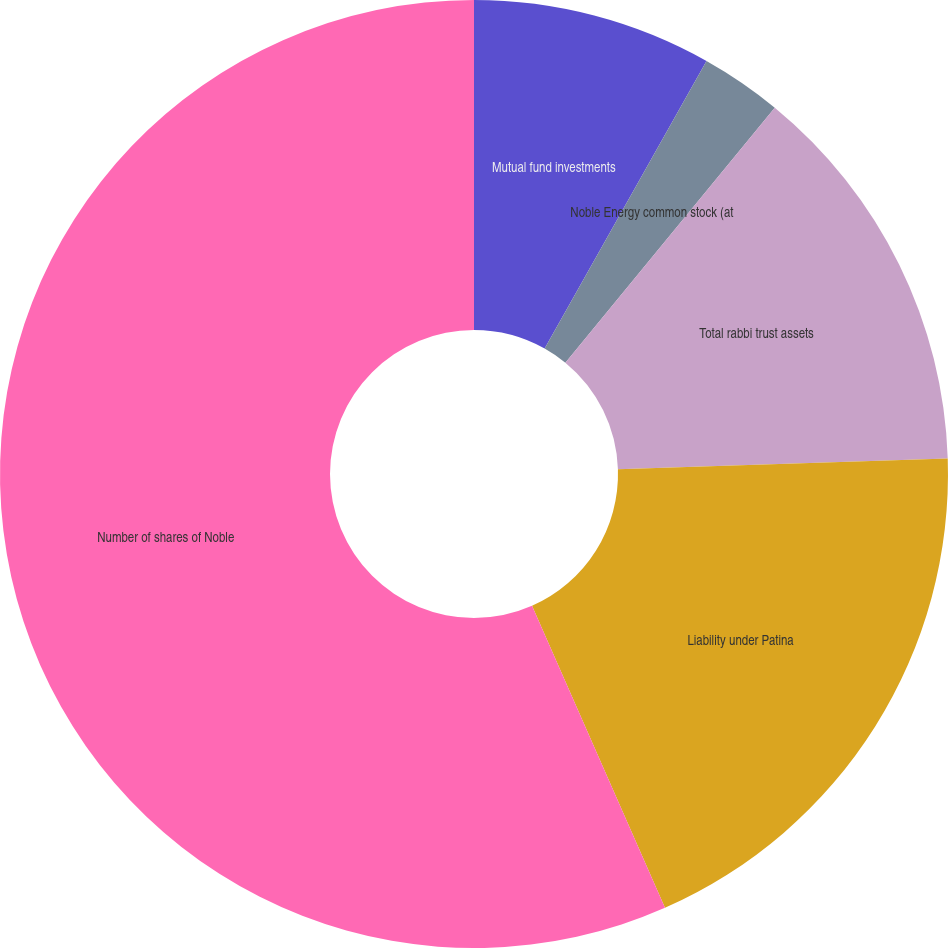<chart> <loc_0><loc_0><loc_500><loc_500><pie_chart><fcel>Mutual fund investments<fcel>Noble Energy common stock (at<fcel>Total rabbi trust assets<fcel>Liability under Patina<fcel>Number of shares of Noble<nl><fcel>8.16%<fcel>2.78%<fcel>13.54%<fcel>18.92%<fcel>56.6%<nl></chart> 